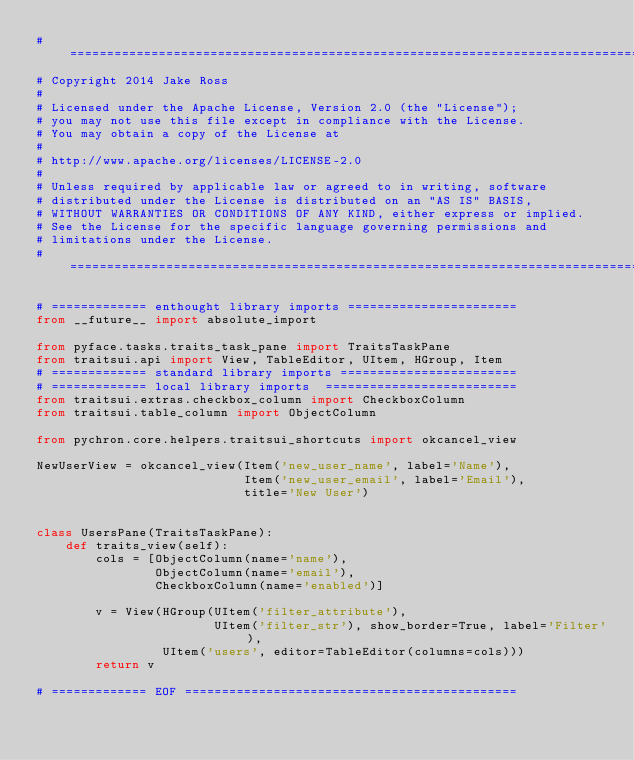Convert code to text. <code><loc_0><loc_0><loc_500><loc_500><_Python_># ===============================================================================
# Copyright 2014 Jake Ross
#
# Licensed under the Apache License, Version 2.0 (the "License");
# you may not use this file except in compliance with the License.
# You may obtain a copy of the License at
#
# http://www.apache.org/licenses/LICENSE-2.0
#
# Unless required by applicable law or agreed to in writing, software
# distributed under the License is distributed on an "AS IS" BASIS,
# WITHOUT WARRANTIES OR CONDITIONS OF ANY KIND, either express or implied.
# See the License for the specific language governing permissions and
# limitations under the License.
# ===============================================================================

# ============= enthought library imports =======================
from __future__ import absolute_import

from pyface.tasks.traits_task_pane import TraitsTaskPane
from traitsui.api import View, TableEditor, UItem, HGroup, Item
# ============= standard library imports ========================
# ============= local library imports  ==========================
from traitsui.extras.checkbox_column import CheckboxColumn
from traitsui.table_column import ObjectColumn

from pychron.core.helpers.traitsui_shortcuts import okcancel_view

NewUserView = okcancel_view(Item('new_user_name', label='Name'),
                            Item('new_user_email', label='Email'),
                            title='New User')


class UsersPane(TraitsTaskPane):
    def traits_view(self):
        cols = [ObjectColumn(name='name'),
                ObjectColumn(name='email'),
                CheckboxColumn(name='enabled')]

        v = View(HGroup(UItem('filter_attribute'),
                        UItem('filter_str'), show_border=True, label='Filter'),
                 UItem('users', editor=TableEditor(columns=cols)))
        return v

# ============= EOF =============================================
</code> 